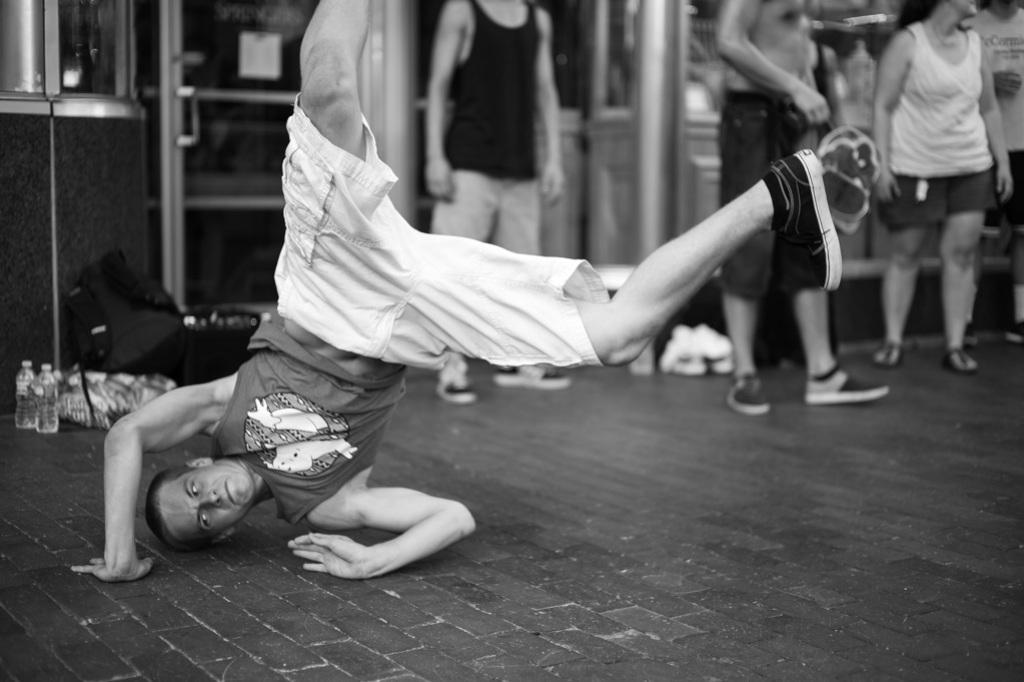What is the person in the image doing? The person in the image is performing exercise. Where is the exercise being done? The exercise is being done on the road. What can be seen in the background of the image? In the background of the image, there are disposable bottles, iron rods, and persons standing on the road. What type of spring can be seen in the image? There is no spring present in the image. What is the exercise being done on the top of in the image? The exercise is being done on the road, not on a top or any other elevated surface. 